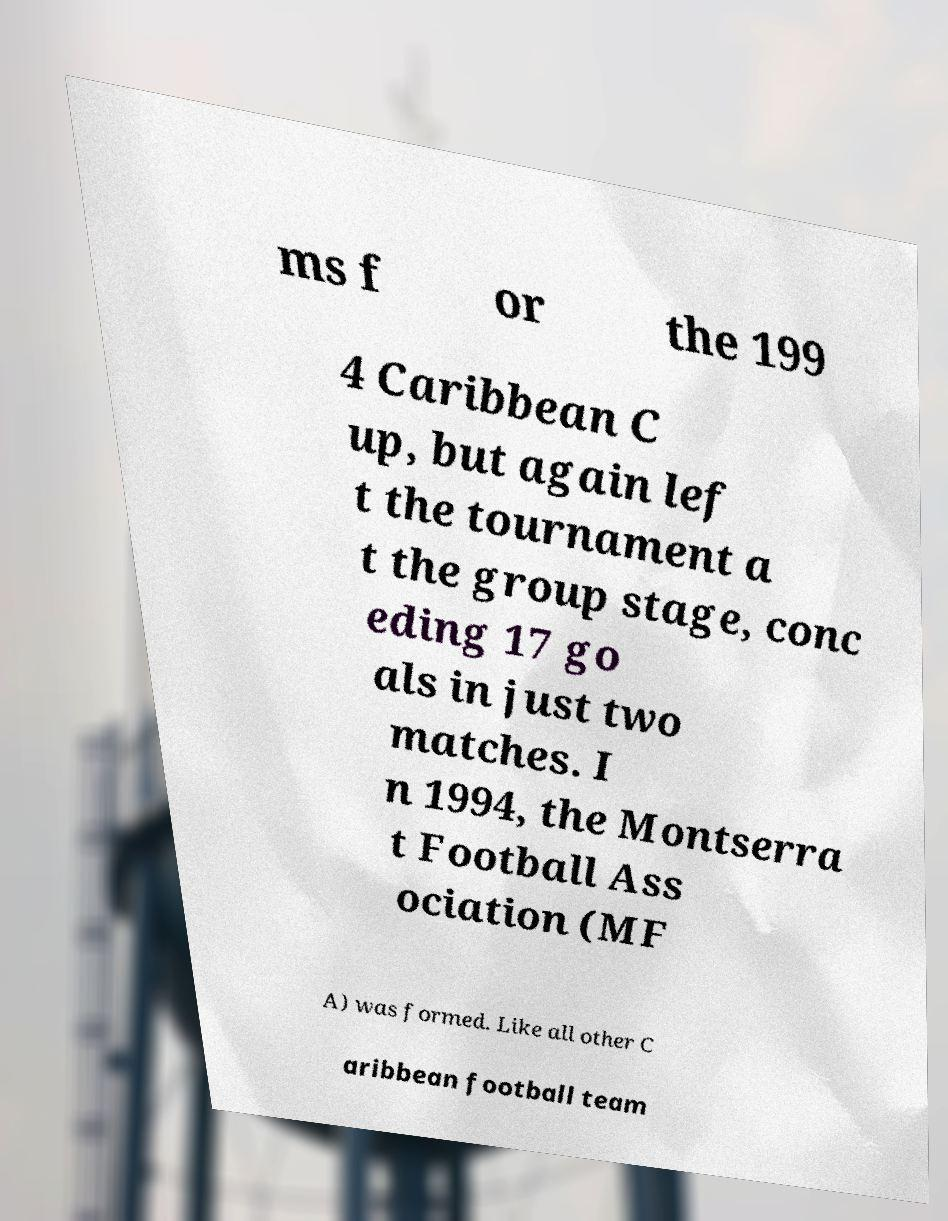For documentation purposes, I need the text within this image transcribed. Could you provide that? ms f or the 199 4 Caribbean C up, but again lef t the tournament a t the group stage, conc eding 17 go als in just two matches. I n 1994, the Montserra t Football Ass ociation (MF A) was formed. Like all other C aribbean football team 